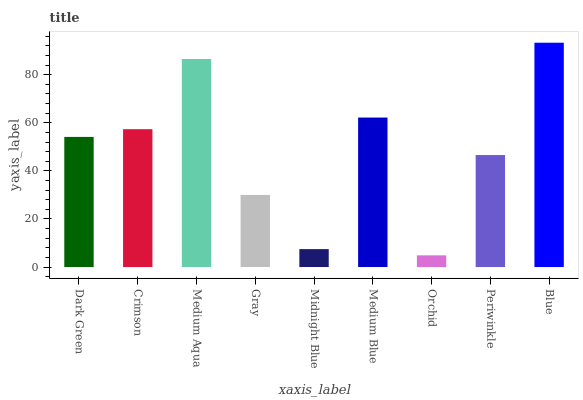Is Orchid the minimum?
Answer yes or no. Yes. Is Blue the maximum?
Answer yes or no. Yes. Is Crimson the minimum?
Answer yes or no. No. Is Crimson the maximum?
Answer yes or no. No. Is Crimson greater than Dark Green?
Answer yes or no. Yes. Is Dark Green less than Crimson?
Answer yes or no. Yes. Is Dark Green greater than Crimson?
Answer yes or no. No. Is Crimson less than Dark Green?
Answer yes or no. No. Is Dark Green the high median?
Answer yes or no. Yes. Is Dark Green the low median?
Answer yes or no. Yes. Is Blue the high median?
Answer yes or no. No. Is Blue the low median?
Answer yes or no. No. 